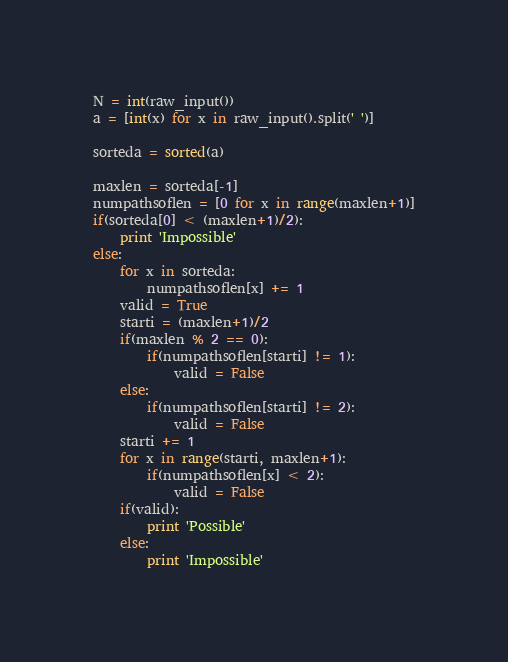Convert code to text. <code><loc_0><loc_0><loc_500><loc_500><_Python_>N = int(raw_input())
a = [int(x) for x in raw_input().split(' ')]

sorteda = sorted(a)

maxlen = sorteda[-1]
numpathsoflen = [0 for x in range(maxlen+1)]
if(sorteda[0] < (maxlen+1)/2):
    print 'Impossible'
else:
    for x in sorteda:
        numpathsoflen[x] += 1            
    valid = True
    starti = (maxlen+1)/2
    if(maxlen % 2 == 0):
        if(numpathsoflen[starti] != 1):
            valid = False
    else:
        if(numpathsoflen[starti] != 2):
            valid = False
    starti += 1        
    for x in range(starti, maxlen+1):
        if(numpathsoflen[x] < 2):
            valid = False
    if(valid):
        print 'Possible'
    else:
        print 'Impossible' </code> 